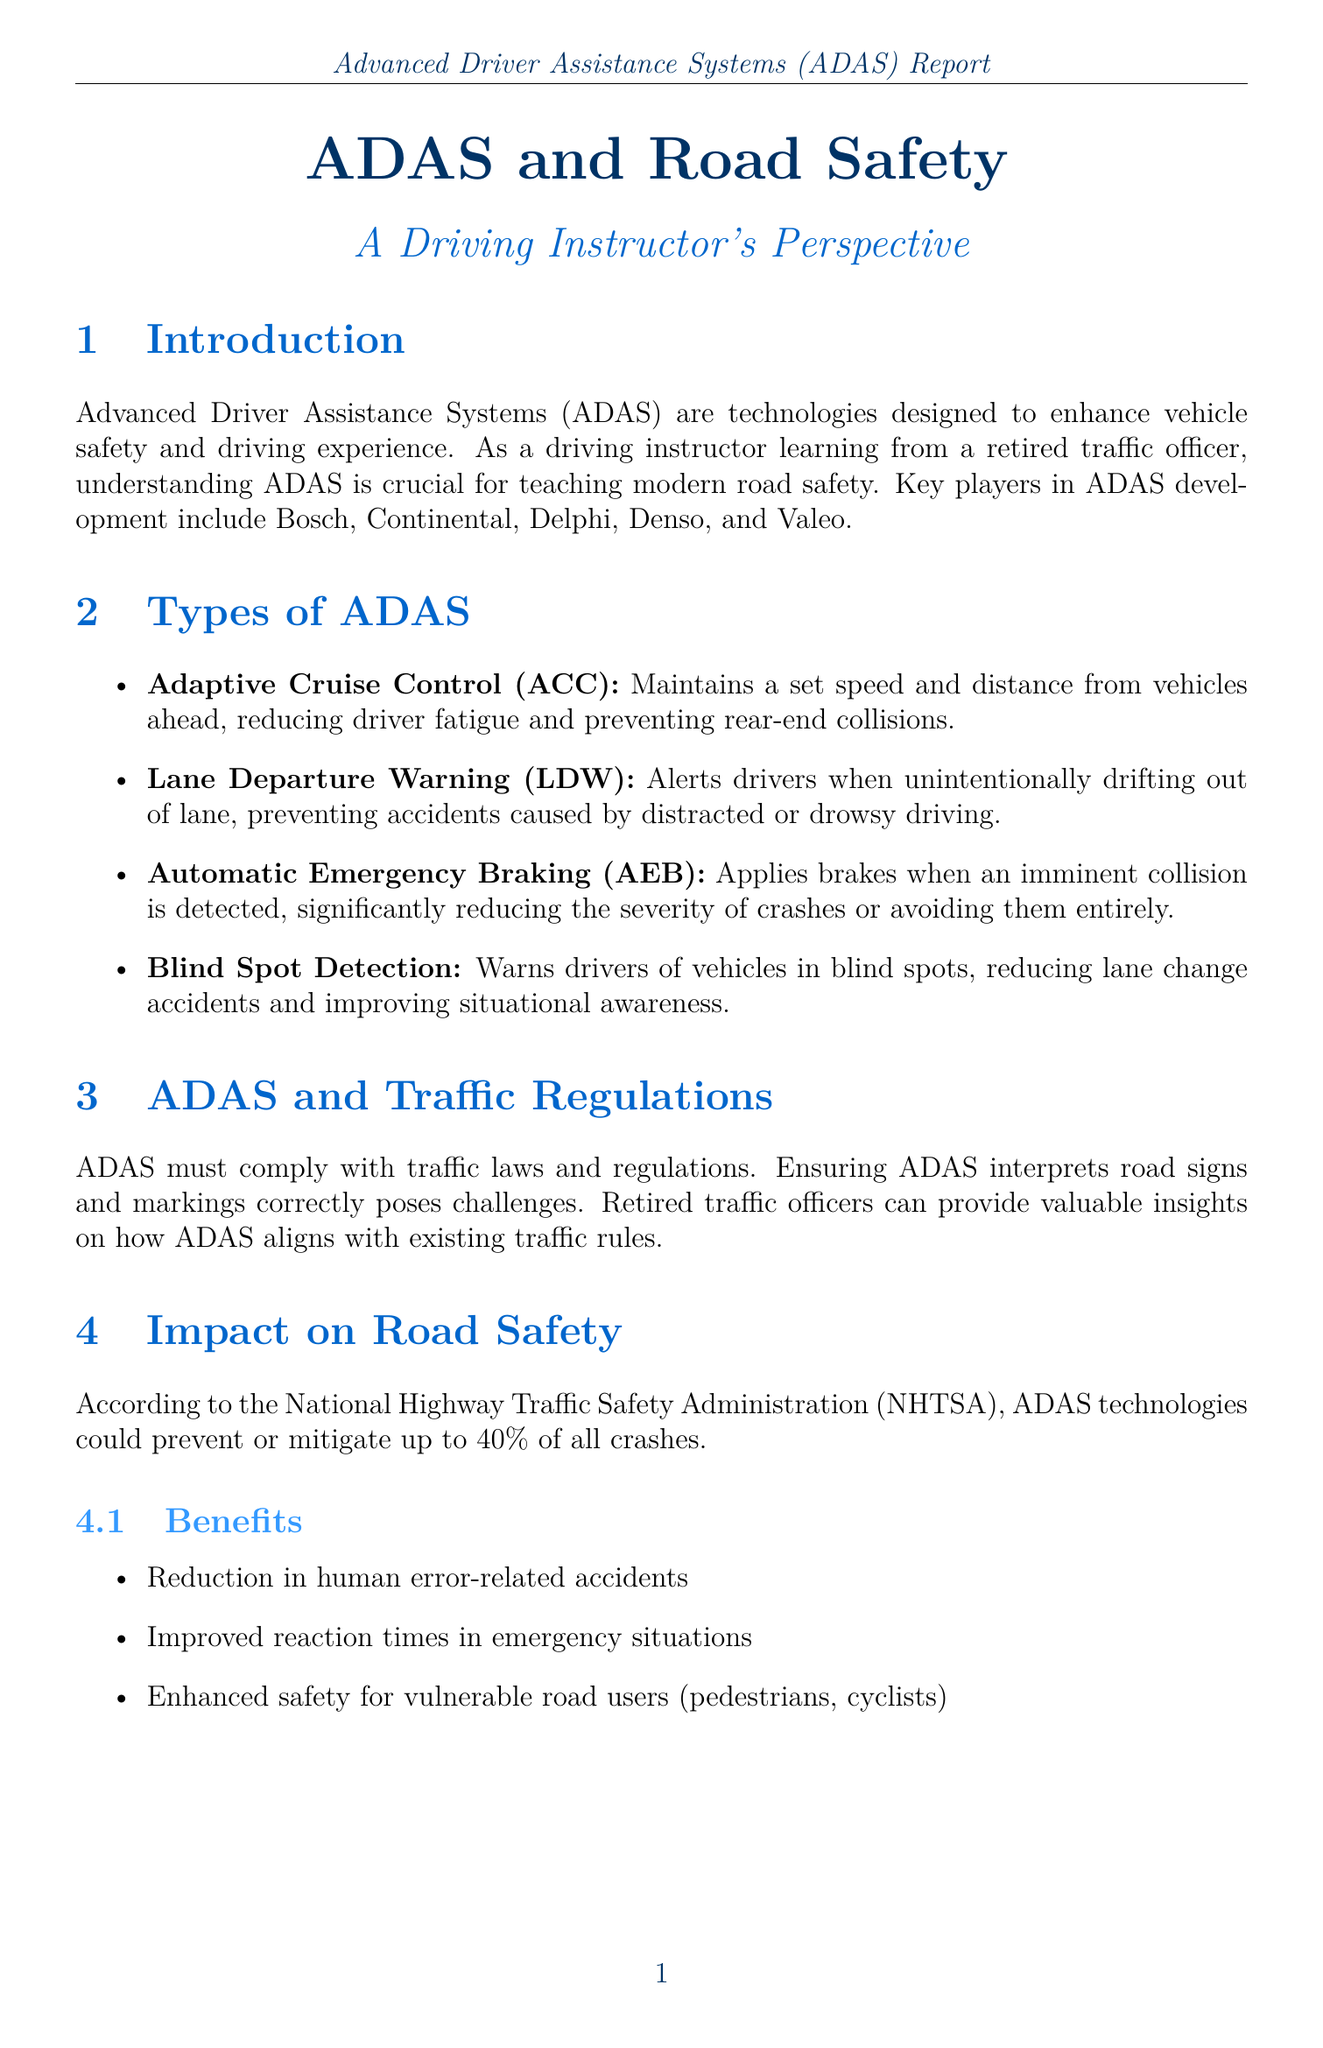What are ADAS technologies designed to enhance? ADAS technologies are designed to enhance vehicle safety and driving experience.
Answer: vehicle safety and driving experience Which key player is mentioned in the ADAS development? Key players in ADAS development include Bosch, Continental, Delphi, Denso, and Valeo.
Answer: Bosch What does Adaptive Cruise Control (ACC) maintain? ACC maintains a set speed and distance from vehicles ahead.
Answer: set speed and distance According to NHTSA, what percentage of crashes could ADAS mitigate? According to NHTSA, ADAS technologies could prevent or mitigate up to 40% of all crashes.
Answer: 40% What is a potential consideration regarding ADAS for drivers? One consideration is the need for proper driver education on ADAS limitations.
Answer: proper driver education on ADAS limitations What is one benefit of ADAS mentioned in the document? Benefits include reduction in human error-related accidents.
Answer: reduction in human error-related accidents What type of communication is mentioned as a future trend for ADAS? Integration with V2X (Vehicle-to-Everything) communication is mentioned as a future trend.
Answer: V2X communication What role do retired traffic officers play in relation to ADAS? Retired traffic officers can provide valuable insights on how ADAS aligns with existing traffic rules.
Answer: valuable insights What is an important aspect instructors should teach about ADAS? Instructors should emphasize the importance of maintaining manual driving skills.
Answer: maintaining manual driving skills 